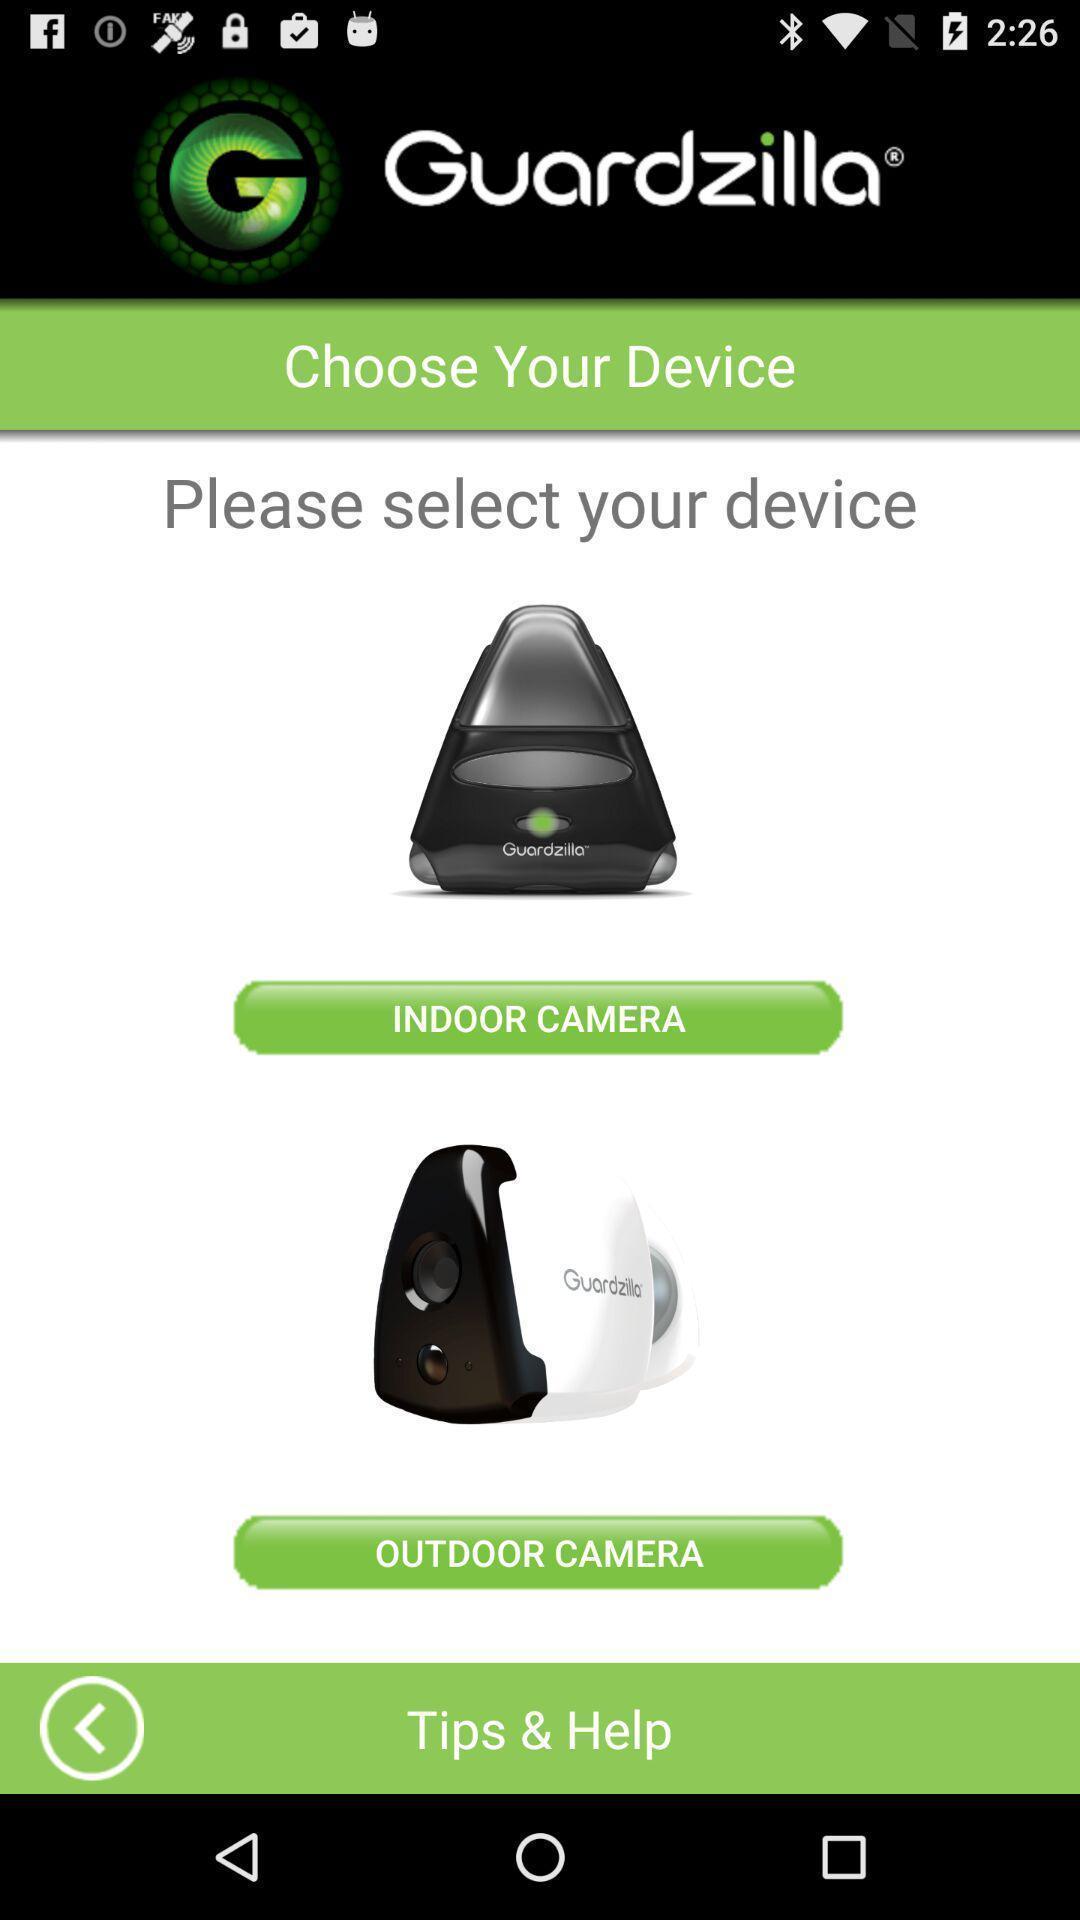What is the overall content of this screenshot? Screen shows to choose device in home security app. 